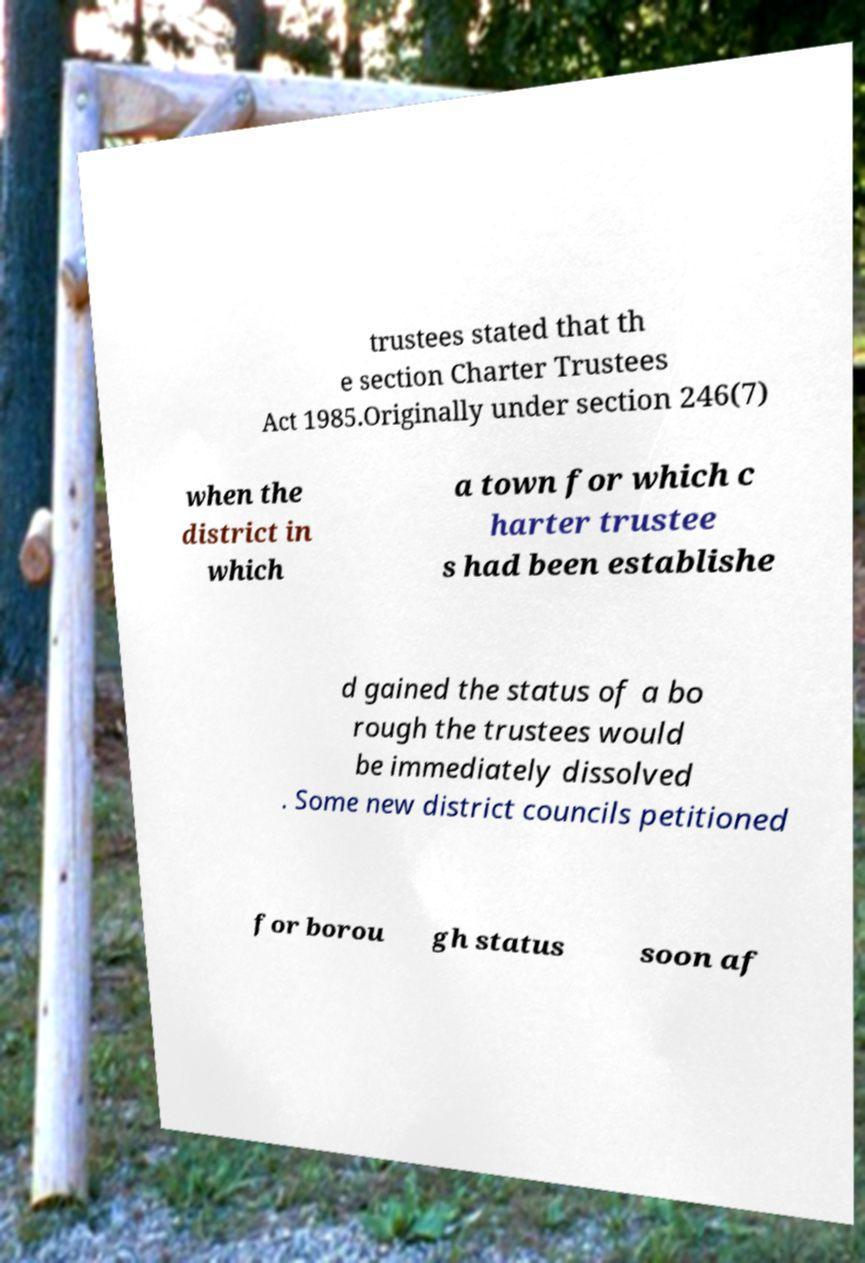I need the written content from this picture converted into text. Can you do that? trustees stated that th e section Charter Trustees Act 1985.Originally under section 246(7) when the district in which a town for which c harter trustee s had been establishe d gained the status of a bo rough the trustees would be immediately dissolved . Some new district councils petitioned for borou gh status soon af 